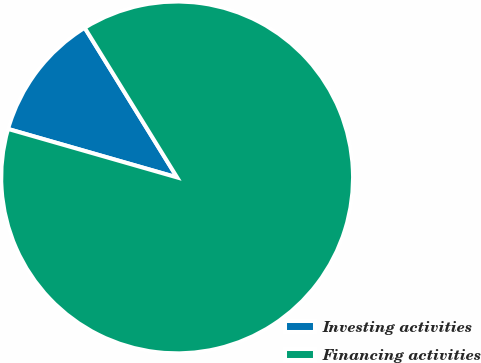Convert chart. <chart><loc_0><loc_0><loc_500><loc_500><pie_chart><fcel>Investing activities<fcel>Financing activities<nl><fcel>11.75%<fcel>88.25%<nl></chart> 